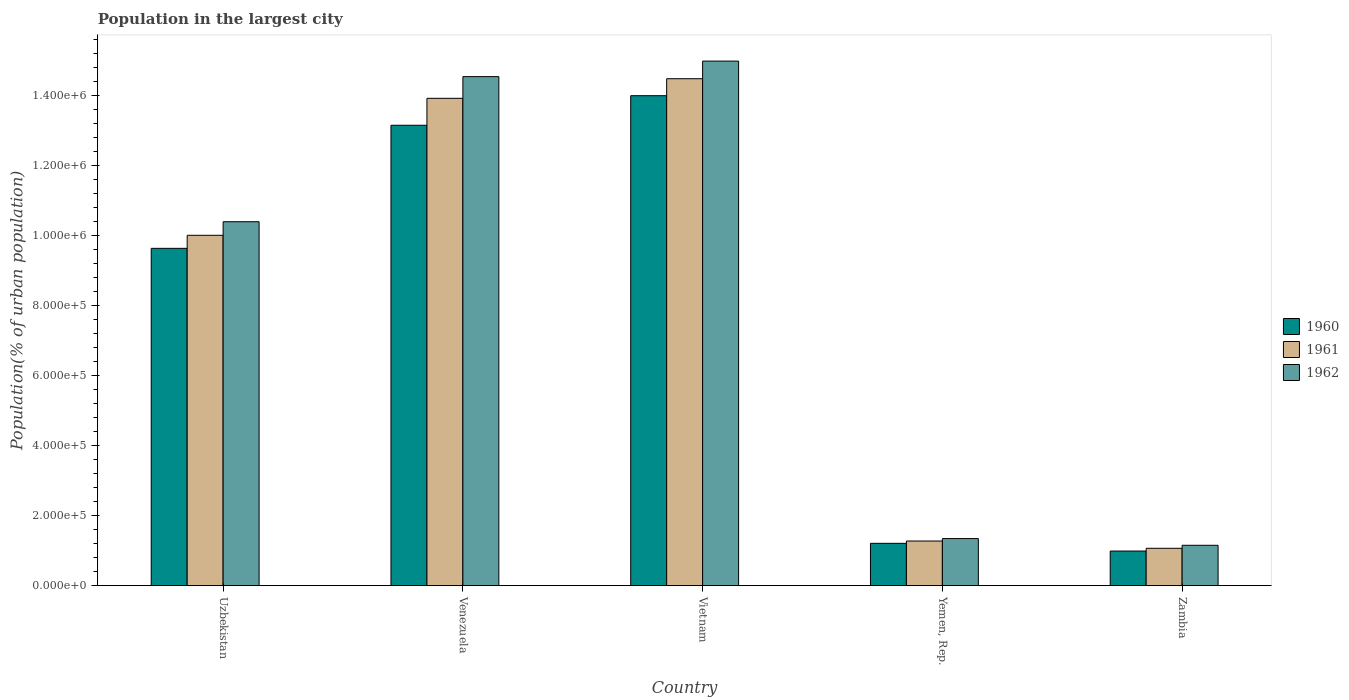How many different coloured bars are there?
Provide a succinct answer. 3. Are the number of bars on each tick of the X-axis equal?
Your response must be concise. Yes. How many bars are there on the 5th tick from the left?
Offer a terse response. 3. How many bars are there on the 5th tick from the right?
Provide a short and direct response. 3. What is the label of the 4th group of bars from the left?
Offer a very short reply. Yemen, Rep. What is the population in the largest city in 1962 in Yemen, Rep.?
Provide a succinct answer. 1.35e+05. Across all countries, what is the maximum population in the largest city in 1960?
Give a very brief answer. 1.40e+06. Across all countries, what is the minimum population in the largest city in 1961?
Give a very brief answer. 1.07e+05. In which country was the population in the largest city in 1960 maximum?
Offer a very short reply. Vietnam. In which country was the population in the largest city in 1960 minimum?
Offer a very short reply. Zambia. What is the total population in the largest city in 1961 in the graph?
Offer a very short reply. 4.08e+06. What is the difference between the population in the largest city in 1961 in Uzbekistan and that in Venezuela?
Provide a short and direct response. -3.91e+05. What is the difference between the population in the largest city in 1962 in Venezuela and the population in the largest city in 1961 in Zambia?
Provide a succinct answer. 1.35e+06. What is the average population in the largest city in 1961 per country?
Make the answer very short. 8.15e+05. What is the difference between the population in the largest city of/in 1960 and population in the largest city of/in 1962 in Vietnam?
Keep it short and to the point. -9.89e+04. In how many countries, is the population in the largest city in 1961 greater than 600000 %?
Make the answer very short. 3. What is the ratio of the population in the largest city in 1962 in Venezuela to that in Yemen, Rep.?
Give a very brief answer. 10.8. What is the difference between the highest and the second highest population in the largest city in 1960?
Ensure brevity in your answer.  8.45e+04. What is the difference between the highest and the lowest population in the largest city in 1960?
Make the answer very short. 1.30e+06. In how many countries, is the population in the largest city in 1960 greater than the average population in the largest city in 1960 taken over all countries?
Your answer should be compact. 3. Is the sum of the population in the largest city in 1960 in Uzbekistan and Yemen, Rep. greater than the maximum population in the largest city in 1962 across all countries?
Provide a short and direct response. No. What does the 1st bar from the left in Yemen, Rep. represents?
Keep it short and to the point. 1960. What does the 1st bar from the right in Vietnam represents?
Your answer should be compact. 1962. Is it the case that in every country, the sum of the population in the largest city in 1960 and population in the largest city in 1962 is greater than the population in the largest city in 1961?
Offer a very short reply. Yes. How many bars are there?
Give a very brief answer. 15. Are all the bars in the graph horizontal?
Offer a terse response. No. Are the values on the major ticks of Y-axis written in scientific E-notation?
Ensure brevity in your answer.  Yes. Does the graph contain any zero values?
Offer a terse response. No. What is the title of the graph?
Give a very brief answer. Population in the largest city. Does "2003" appear as one of the legend labels in the graph?
Offer a very short reply. No. What is the label or title of the X-axis?
Ensure brevity in your answer.  Country. What is the label or title of the Y-axis?
Give a very brief answer. Population(% of urban population). What is the Population(% of urban population) in 1960 in Uzbekistan?
Your answer should be very brief. 9.64e+05. What is the Population(% of urban population) of 1961 in Uzbekistan?
Provide a short and direct response. 1.00e+06. What is the Population(% of urban population) of 1962 in Uzbekistan?
Your answer should be very brief. 1.04e+06. What is the Population(% of urban population) of 1960 in Venezuela?
Provide a short and direct response. 1.32e+06. What is the Population(% of urban population) in 1961 in Venezuela?
Ensure brevity in your answer.  1.39e+06. What is the Population(% of urban population) of 1962 in Venezuela?
Your answer should be compact. 1.45e+06. What is the Population(% of urban population) of 1960 in Vietnam?
Make the answer very short. 1.40e+06. What is the Population(% of urban population) in 1961 in Vietnam?
Provide a succinct answer. 1.45e+06. What is the Population(% of urban population) of 1962 in Vietnam?
Provide a short and direct response. 1.50e+06. What is the Population(% of urban population) of 1960 in Yemen, Rep.?
Your answer should be very brief. 1.21e+05. What is the Population(% of urban population) in 1961 in Yemen, Rep.?
Your response must be concise. 1.28e+05. What is the Population(% of urban population) in 1962 in Yemen, Rep.?
Provide a succinct answer. 1.35e+05. What is the Population(% of urban population) in 1960 in Zambia?
Provide a succinct answer. 9.90e+04. What is the Population(% of urban population) of 1961 in Zambia?
Your answer should be very brief. 1.07e+05. What is the Population(% of urban population) of 1962 in Zambia?
Your response must be concise. 1.15e+05. Across all countries, what is the maximum Population(% of urban population) of 1960?
Your answer should be very brief. 1.40e+06. Across all countries, what is the maximum Population(% of urban population) of 1961?
Your answer should be very brief. 1.45e+06. Across all countries, what is the maximum Population(% of urban population) in 1962?
Give a very brief answer. 1.50e+06. Across all countries, what is the minimum Population(% of urban population) in 1960?
Offer a terse response. 9.90e+04. Across all countries, what is the minimum Population(% of urban population) of 1961?
Ensure brevity in your answer.  1.07e+05. Across all countries, what is the minimum Population(% of urban population) in 1962?
Provide a short and direct response. 1.15e+05. What is the total Population(% of urban population) of 1960 in the graph?
Keep it short and to the point. 3.90e+06. What is the total Population(% of urban population) in 1961 in the graph?
Make the answer very short. 4.08e+06. What is the total Population(% of urban population) of 1962 in the graph?
Give a very brief answer. 4.24e+06. What is the difference between the Population(% of urban population) in 1960 in Uzbekistan and that in Venezuela?
Provide a short and direct response. -3.52e+05. What is the difference between the Population(% of urban population) of 1961 in Uzbekistan and that in Venezuela?
Make the answer very short. -3.91e+05. What is the difference between the Population(% of urban population) in 1962 in Uzbekistan and that in Venezuela?
Give a very brief answer. -4.15e+05. What is the difference between the Population(% of urban population) in 1960 in Uzbekistan and that in Vietnam?
Offer a very short reply. -4.36e+05. What is the difference between the Population(% of urban population) in 1961 in Uzbekistan and that in Vietnam?
Provide a succinct answer. -4.47e+05. What is the difference between the Population(% of urban population) in 1962 in Uzbekistan and that in Vietnam?
Offer a very short reply. -4.59e+05. What is the difference between the Population(% of urban population) of 1960 in Uzbekistan and that in Yemen, Rep.?
Your response must be concise. 8.43e+05. What is the difference between the Population(% of urban population) of 1961 in Uzbekistan and that in Yemen, Rep.?
Your answer should be very brief. 8.74e+05. What is the difference between the Population(% of urban population) in 1962 in Uzbekistan and that in Yemen, Rep.?
Make the answer very short. 9.05e+05. What is the difference between the Population(% of urban population) in 1960 in Uzbekistan and that in Zambia?
Your answer should be very brief. 8.65e+05. What is the difference between the Population(% of urban population) of 1961 in Uzbekistan and that in Zambia?
Make the answer very short. 8.94e+05. What is the difference between the Population(% of urban population) of 1962 in Uzbekistan and that in Zambia?
Your answer should be very brief. 9.25e+05. What is the difference between the Population(% of urban population) of 1960 in Venezuela and that in Vietnam?
Your answer should be compact. -8.45e+04. What is the difference between the Population(% of urban population) of 1961 in Venezuela and that in Vietnam?
Provide a succinct answer. -5.60e+04. What is the difference between the Population(% of urban population) in 1962 in Venezuela and that in Vietnam?
Make the answer very short. -4.44e+04. What is the difference between the Population(% of urban population) in 1960 in Venezuela and that in Yemen, Rep.?
Your response must be concise. 1.19e+06. What is the difference between the Population(% of urban population) in 1961 in Venezuela and that in Yemen, Rep.?
Your answer should be very brief. 1.26e+06. What is the difference between the Population(% of urban population) in 1962 in Venezuela and that in Yemen, Rep.?
Offer a terse response. 1.32e+06. What is the difference between the Population(% of urban population) in 1960 in Venezuela and that in Zambia?
Provide a succinct answer. 1.22e+06. What is the difference between the Population(% of urban population) of 1961 in Venezuela and that in Zambia?
Offer a very short reply. 1.29e+06. What is the difference between the Population(% of urban population) in 1962 in Venezuela and that in Zambia?
Offer a very short reply. 1.34e+06. What is the difference between the Population(% of urban population) of 1960 in Vietnam and that in Yemen, Rep.?
Give a very brief answer. 1.28e+06. What is the difference between the Population(% of urban population) in 1961 in Vietnam and that in Yemen, Rep.?
Give a very brief answer. 1.32e+06. What is the difference between the Population(% of urban population) of 1962 in Vietnam and that in Yemen, Rep.?
Give a very brief answer. 1.36e+06. What is the difference between the Population(% of urban population) in 1960 in Vietnam and that in Zambia?
Provide a short and direct response. 1.30e+06. What is the difference between the Population(% of urban population) in 1961 in Vietnam and that in Zambia?
Give a very brief answer. 1.34e+06. What is the difference between the Population(% of urban population) of 1962 in Vietnam and that in Zambia?
Ensure brevity in your answer.  1.38e+06. What is the difference between the Population(% of urban population) of 1960 in Yemen, Rep. and that in Zambia?
Your answer should be very brief. 2.20e+04. What is the difference between the Population(% of urban population) in 1961 in Yemen, Rep. and that in Zambia?
Your response must be concise. 2.08e+04. What is the difference between the Population(% of urban population) in 1962 in Yemen, Rep. and that in Zambia?
Your answer should be very brief. 1.92e+04. What is the difference between the Population(% of urban population) in 1960 in Uzbekistan and the Population(% of urban population) in 1961 in Venezuela?
Your answer should be compact. -4.29e+05. What is the difference between the Population(% of urban population) of 1960 in Uzbekistan and the Population(% of urban population) of 1962 in Venezuela?
Offer a terse response. -4.91e+05. What is the difference between the Population(% of urban population) in 1961 in Uzbekistan and the Population(% of urban population) in 1962 in Venezuela?
Offer a very short reply. -4.53e+05. What is the difference between the Population(% of urban population) in 1960 in Uzbekistan and the Population(% of urban population) in 1961 in Vietnam?
Your answer should be very brief. -4.85e+05. What is the difference between the Population(% of urban population) in 1960 in Uzbekistan and the Population(% of urban population) in 1962 in Vietnam?
Offer a terse response. -5.35e+05. What is the difference between the Population(% of urban population) in 1961 in Uzbekistan and the Population(% of urban population) in 1962 in Vietnam?
Offer a very short reply. -4.98e+05. What is the difference between the Population(% of urban population) of 1960 in Uzbekistan and the Population(% of urban population) of 1961 in Yemen, Rep.?
Offer a terse response. 8.36e+05. What is the difference between the Population(% of urban population) in 1960 in Uzbekistan and the Population(% of urban population) in 1962 in Yemen, Rep.?
Make the answer very short. 8.29e+05. What is the difference between the Population(% of urban population) of 1961 in Uzbekistan and the Population(% of urban population) of 1962 in Yemen, Rep.?
Give a very brief answer. 8.67e+05. What is the difference between the Population(% of urban population) of 1960 in Uzbekistan and the Population(% of urban population) of 1961 in Zambia?
Your response must be concise. 8.57e+05. What is the difference between the Population(% of urban population) in 1960 in Uzbekistan and the Population(% of urban population) in 1962 in Zambia?
Give a very brief answer. 8.49e+05. What is the difference between the Population(% of urban population) of 1961 in Uzbekistan and the Population(% of urban population) of 1962 in Zambia?
Keep it short and to the point. 8.86e+05. What is the difference between the Population(% of urban population) in 1960 in Venezuela and the Population(% of urban population) in 1961 in Vietnam?
Provide a succinct answer. -1.33e+05. What is the difference between the Population(% of urban population) in 1960 in Venezuela and the Population(% of urban population) in 1962 in Vietnam?
Provide a short and direct response. -1.83e+05. What is the difference between the Population(% of urban population) in 1961 in Venezuela and the Population(% of urban population) in 1962 in Vietnam?
Your answer should be compact. -1.06e+05. What is the difference between the Population(% of urban population) in 1960 in Venezuela and the Population(% of urban population) in 1961 in Yemen, Rep.?
Provide a short and direct response. 1.19e+06. What is the difference between the Population(% of urban population) of 1960 in Venezuela and the Population(% of urban population) of 1962 in Yemen, Rep.?
Your response must be concise. 1.18e+06. What is the difference between the Population(% of urban population) in 1961 in Venezuela and the Population(% of urban population) in 1962 in Yemen, Rep.?
Offer a very short reply. 1.26e+06. What is the difference between the Population(% of urban population) in 1960 in Venezuela and the Population(% of urban population) in 1961 in Zambia?
Your answer should be compact. 1.21e+06. What is the difference between the Population(% of urban population) in 1960 in Venezuela and the Population(% of urban population) in 1962 in Zambia?
Provide a short and direct response. 1.20e+06. What is the difference between the Population(% of urban population) in 1961 in Venezuela and the Population(% of urban population) in 1962 in Zambia?
Give a very brief answer. 1.28e+06. What is the difference between the Population(% of urban population) of 1960 in Vietnam and the Population(% of urban population) of 1961 in Yemen, Rep.?
Offer a terse response. 1.27e+06. What is the difference between the Population(% of urban population) of 1960 in Vietnam and the Population(% of urban population) of 1962 in Yemen, Rep.?
Your answer should be compact. 1.27e+06. What is the difference between the Population(% of urban population) of 1961 in Vietnam and the Population(% of urban population) of 1962 in Yemen, Rep.?
Make the answer very short. 1.31e+06. What is the difference between the Population(% of urban population) of 1960 in Vietnam and the Population(% of urban population) of 1961 in Zambia?
Ensure brevity in your answer.  1.29e+06. What is the difference between the Population(% of urban population) in 1960 in Vietnam and the Population(% of urban population) in 1962 in Zambia?
Make the answer very short. 1.28e+06. What is the difference between the Population(% of urban population) of 1961 in Vietnam and the Population(% of urban population) of 1962 in Zambia?
Keep it short and to the point. 1.33e+06. What is the difference between the Population(% of urban population) of 1960 in Yemen, Rep. and the Population(% of urban population) of 1961 in Zambia?
Ensure brevity in your answer.  1.41e+04. What is the difference between the Population(% of urban population) of 1960 in Yemen, Rep. and the Population(% of urban population) of 1962 in Zambia?
Keep it short and to the point. 5601. What is the difference between the Population(% of urban population) of 1961 in Yemen, Rep. and the Population(% of urban population) of 1962 in Zambia?
Make the answer very short. 1.22e+04. What is the average Population(% of urban population) of 1960 per country?
Give a very brief answer. 7.80e+05. What is the average Population(% of urban population) in 1961 per country?
Offer a terse response. 8.15e+05. What is the average Population(% of urban population) of 1962 per country?
Provide a succinct answer. 8.49e+05. What is the difference between the Population(% of urban population) in 1960 and Population(% of urban population) in 1961 in Uzbekistan?
Provide a short and direct response. -3.73e+04. What is the difference between the Population(% of urban population) in 1960 and Population(% of urban population) in 1962 in Uzbekistan?
Give a very brief answer. -7.60e+04. What is the difference between the Population(% of urban population) in 1961 and Population(% of urban population) in 1962 in Uzbekistan?
Your answer should be very brief. -3.88e+04. What is the difference between the Population(% of urban population) of 1960 and Population(% of urban population) of 1961 in Venezuela?
Your response must be concise. -7.70e+04. What is the difference between the Population(% of urban population) in 1960 and Population(% of urban population) in 1962 in Venezuela?
Offer a very short reply. -1.39e+05. What is the difference between the Population(% of urban population) of 1961 and Population(% of urban population) of 1962 in Venezuela?
Give a very brief answer. -6.19e+04. What is the difference between the Population(% of urban population) of 1960 and Population(% of urban population) of 1961 in Vietnam?
Provide a short and direct response. -4.86e+04. What is the difference between the Population(% of urban population) of 1960 and Population(% of urban population) of 1962 in Vietnam?
Provide a succinct answer. -9.89e+04. What is the difference between the Population(% of urban population) in 1961 and Population(% of urban population) in 1962 in Vietnam?
Ensure brevity in your answer.  -5.03e+04. What is the difference between the Population(% of urban population) in 1960 and Population(% of urban population) in 1961 in Yemen, Rep.?
Give a very brief answer. -6622. What is the difference between the Population(% of urban population) in 1960 and Population(% of urban population) in 1962 in Yemen, Rep.?
Your response must be concise. -1.36e+04. What is the difference between the Population(% of urban population) of 1961 and Population(% of urban population) of 1962 in Yemen, Rep.?
Your answer should be compact. -6994. What is the difference between the Population(% of urban population) of 1960 and Population(% of urban population) of 1961 in Zambia?
Your answer should be very brief. -7895. What is the difference between the Population(% of urban population) of 1960 and Population(% of urban population) of 1962 in Zambia?
Provide a succinct answer. -1.64e+04. What is the difference between the Population(% of urban population) in 1961 and Population(% of urban population) in 1962 in Zambia?
Provide a succinct answer. -8536. What is the ratio of the Population(% of urban population) in 1960 in Uzbekistan to that in Venezuela?
Keep it short and to the point. 0.73. What is the ratio of the Population(% of urban population) in 1961 in Uzbekistan to that in Venezuela?
Offer a terse response. 0.72. What is the ratio of the Population(% of urban population) of 1962 in Uzbekistan to that in Venezuela?
Your response must be concise. 0.71. What is the ratio of the Population(% of urban population) of 1960 in Uzbekistan to that in Vietnam?
Give a very brief answer. 0.69. What is the ratio of the Population(% of urban population) of 1961 in Uzbekistan to that in Vietnam?
Your answer should be compact. 0.69. What is the ratio of the Population(% of urban population) of 1962 in Uzbekistan to that in Vietnam?
Provide a succinct answer. 0.69. What is the ratio of the Population(% of urban population) of 1960 in Uzbekistan to that in Yemen, Rep.?
Your response must be concise. 7.97. What is the ratio of the Population(% of urban population) in 1961 in Uzbekistan to that in Yemen, Rep.?
Offer a terse response. 7.84. What is the ratio of the Population(% of urban population) in 1962 in Uzbekistan to that in Yemen, Rep.?
Offer a terse response. 7.73. What is the ratio of the Population(% of urban population) of 1960 in Uzbekistan to that in Zambia?
Your response must be concise. 9.74. What is the ratio of the Population(% of urban population) in 1961 in Uzbekistan to that in Zambia?
Provide a succinct answer. 9.37. What is the ratio of the Population(% of urban population) in 1962 in Uzbekistan to that in Zambia?
Ensure brevity in your answer.  9.01. What is the ratio of the Population(% of urban population) in 1960 in Venezuela to that in Vietnam?
Provide a succinct answer. 0.94. What is the ratio of the Population(% of urban population) of 1961 in Venezuela to that in Vietnam?
Provide a succinct answer. 0.96. What is the ratio of the Population(% of urban population) of 1962 in Venezuela to that in Vietnam?
Your response must be concise. 0.97. What is the ratio of the Population(% of urban population) in 1960 in Venezuela to that in Yemen, Rep.?
Offer a very short reply. 10.87. What is the ratio of the Population(% of urban population) in 1961 in Venezuela to that in Yemen, Rep.?
Give a very brief answer. 10.91. What is the ratio of the Population(% of urban population) in 1962 in Venezuela to that in Yemen, Rep.?
Your answer should be very brief. 10.8. What is the ratio of the Population(% of urban population) of 1960 in Venezuela to that in Zambia?
Provide a succinct answer. 13.29. What is the ratio of the Population(% of urban population) in 1961 in Venezuela to that in Zambia?
Give a very brief answer. 13.03. What is the ratio of the Population(% of urban population) of 1962 in Venezuela to that in Zambia?
Provide a short and direct response. 12.6. What is the ratio of the Population(% of urban population) in 1960 in Vietnam to that in Yemen, Rep.?
Your answer should be compact. 11.57. What is the ratio of the Population(% of urban population) in 1961 in Vietnam to that in Yemen, Rep.?
Make the answer very short. 11.35. What is the ratio of the Population(% of urban population) in 1962 in Vietnam to that in Yemen, Rep.?
Your response must be concise. 11.13. What is the ratio of the Population(% of urban population) in 1960 in Vietnam to that in Zambia?
Provide a short and direct response. 14.15. What is the ratio of the Population(% of urban population) of 1961 in Vietnam to that in Zambia?
Your answer should be compact. 13.56. What is the ratio of the Population(% of urban population) of 1962 in Vietnam to that in Zambia?
Ensure brevity in your answer.  12.99. What is the ratio of the Population(% of urban population) in 1960 in Yemen, Rep. to that in Zambia?
Keep it short and to the point. 1.22. What is the ratio of the Population(% of urban population) of 1961 in Yemen, Rep. to that in Zambia?
Provide a short and direct response. 1.19. What is the ratio of the Population(% of urban population) in 1962 in Yemen, Rep. to that in Zambia?
Provide a short and direct response. 1.17. What is the difference between the highest and the second highest Population(% of urban population) of 1960?
Your answer should be very brief. 8.45e+04. What is the difference between the highest and the second highest Population(% of urban population) in 1961?
Your answer should be compact. 5.60e+04. What is the difference between the highest and the second highest Population(% of urban population) of 1962?
Ensure brevity in your answer.  4.44e+04. What is the difference between the highest and the lowest Population(% of urban population) of 1960?
Ensure brevity in your answer.  1.30e+06. What is the difference between the highest and the lowest Population(% of urban population) in 1961?
Provide a short and direct response. 1.34e+06. What is the difference between the highest and the lowest Population(% of urban population) in 1962?
Ensure brevity in your answer.  1.38e+06. 